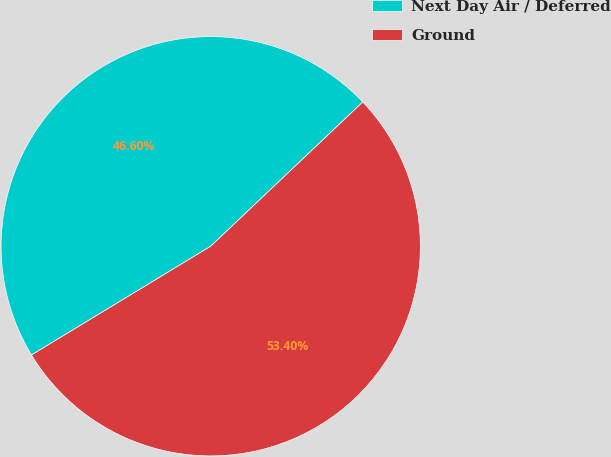Convert chart to OTSL. <chart><loc_0><loc_0><loc_500><loc_500><pie_chart><fcel>Next Day Air / Deferred<fcel>Ground<nl><fcel>46.6%<fcel>53.4%<nl></chart> 